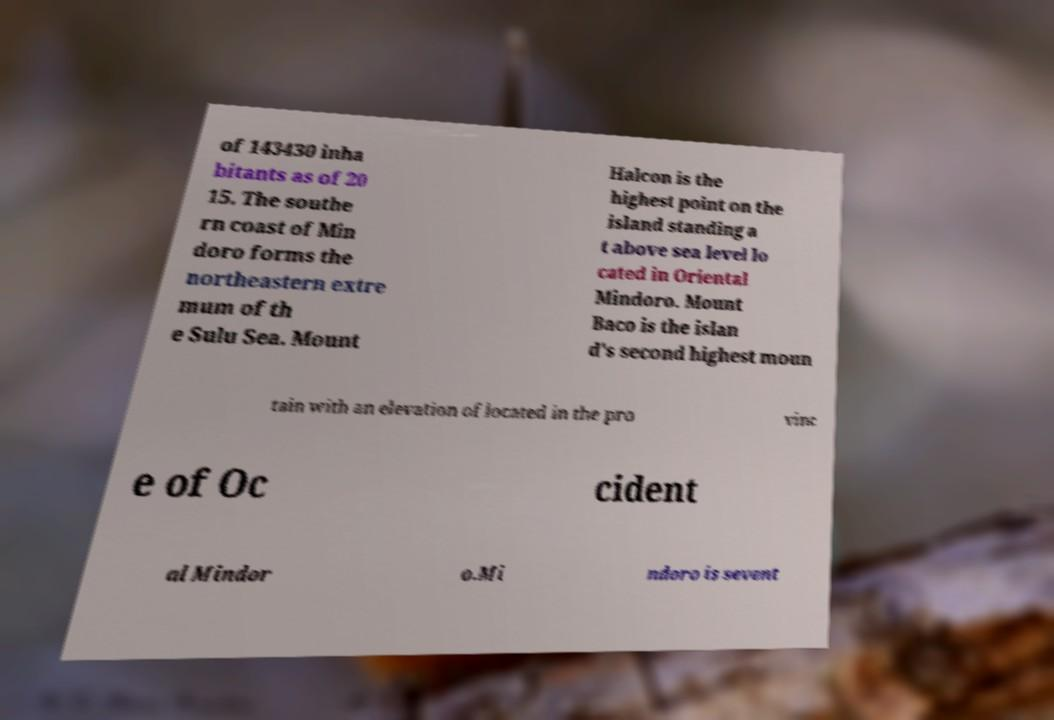Could you extract and type out the text from this image? of 143430 inha bitants as of 20 15. The southe rn coast of Min doro forms the northeastern extre mum of th e Sulu Sea. Mount Halcon is the highest point on the island standing a t above sea level lo cated in Oriental Mindoro. Mount Baco is the islan d's second highest moun tain with an elevation of located in the pro vinc e of Oc cident al Mindor o.Mi ndoro is sevent 